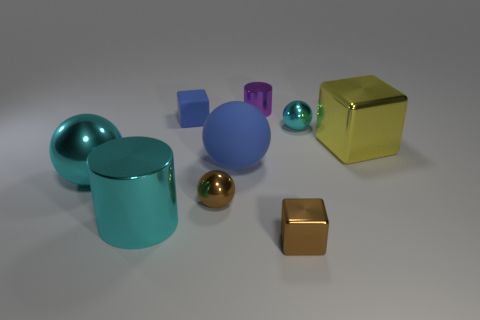What number of other objects are there of the same shape as the big rubber thing?
Your response must be concise. 3. There is a cube that is to the right of the blue matte block and behind the blue sphere; what material is it made of?
Make the answer very short. Metal. What number of things are small purple shiny cylinders or big gray cubes?
Give a very brief answer. 1. Is the number of metallic cylinders greater than the number of yellow metal things?
Your answer should be very brief. Yes. There is a cyan shiny object that is in front of the small brown thing left of the purple shiny cylinder; how big is it?
Your response must be concise. Large. What color is the big object that is the same shape as the small purple thing?
Offer a very short reply. Cyan. What size is the cyan metallic cylinder?
Provide a succinct answer. Large. What number of balls are yellow things or large cyan metallic objects?
Offer a terse response. 1. There is a blue thing that is the same shape as the yellow shiny object; what is its size?
Provide a short and direct response. Small. How many tiny cyan shiny objects are there?
Your answer should be very brief. 1. 